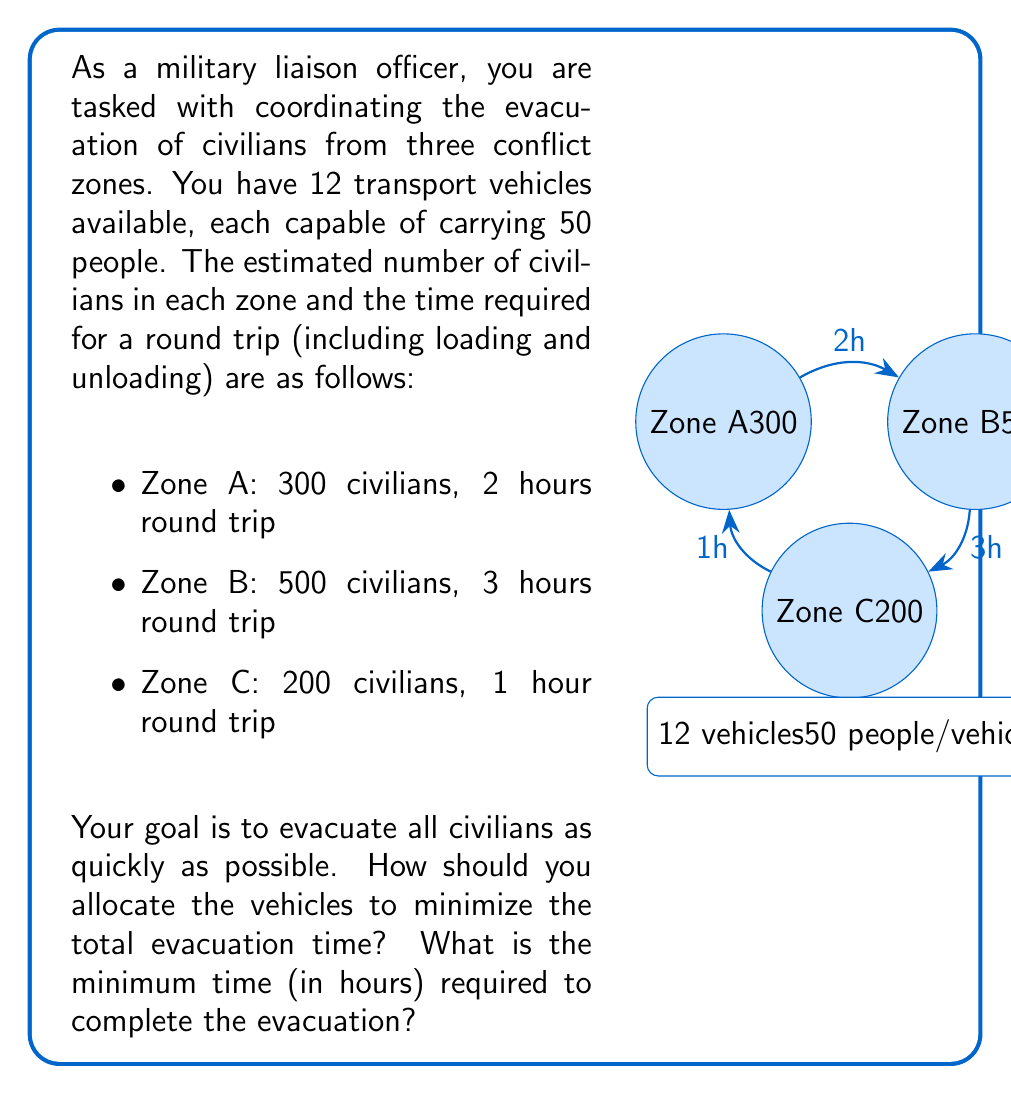What is the answer to this math problem? Let's approach this problem step-by-step using decision theory and resource allocation principles:

1) First, calculate the number of trips required for each zone:
   Zone A: $\ceil{\frac{300}{50}} = 6$ trips
   Zone B: $\ceil{\frac{500}{50}} = 10$ trips
   Zone C: $\ceil{\frac{200}{50}} = 4$ trips

2) Calculate the total time required if all trips were done sequentially:
   Zone A: $6 \times 2 = 12$ hours
   Zone B: $10 \times 3 = 30$ hours
   Zone C: $4 \times 1 = 4$ hours
   Total: 46 hours

3) To minimize time, we need to parallelize the evacuation. The optimal strategy is to allocate vehicles proportionally to the time required for each zone.

4) Calculate the proportion of time for each zone:
   Zone A: $12 / 46 \approx 0.261$
   Zone B: $30 / 46 \approx 0.652$
   Zone C: $4 / 46 \approx 0.087$

5) Allocate vehicles based on these proportions:
   Zone A: $0.261 \times 12 \approx 3$ vehicles
   Zone B: $0.652 \times 12 \approx 8$ vehicles
   Zone C: $0.087 \times 12 \approx 1$ vehicle

6) Calculate the time required with this allocation:
   Zone A: $\ceil{\frac{6}{3}} \times 2 = 4$ hours
   Zone B: $\ceil{\frac{10}{8}} \times 3 = 6$ hours
   Zone C: $\ceil{\frac{4}{1}} \times 1 = 4$ hours

7) The total evacuation time is the maximum of these times, which is 6 hours.
Answer: 6 hours 